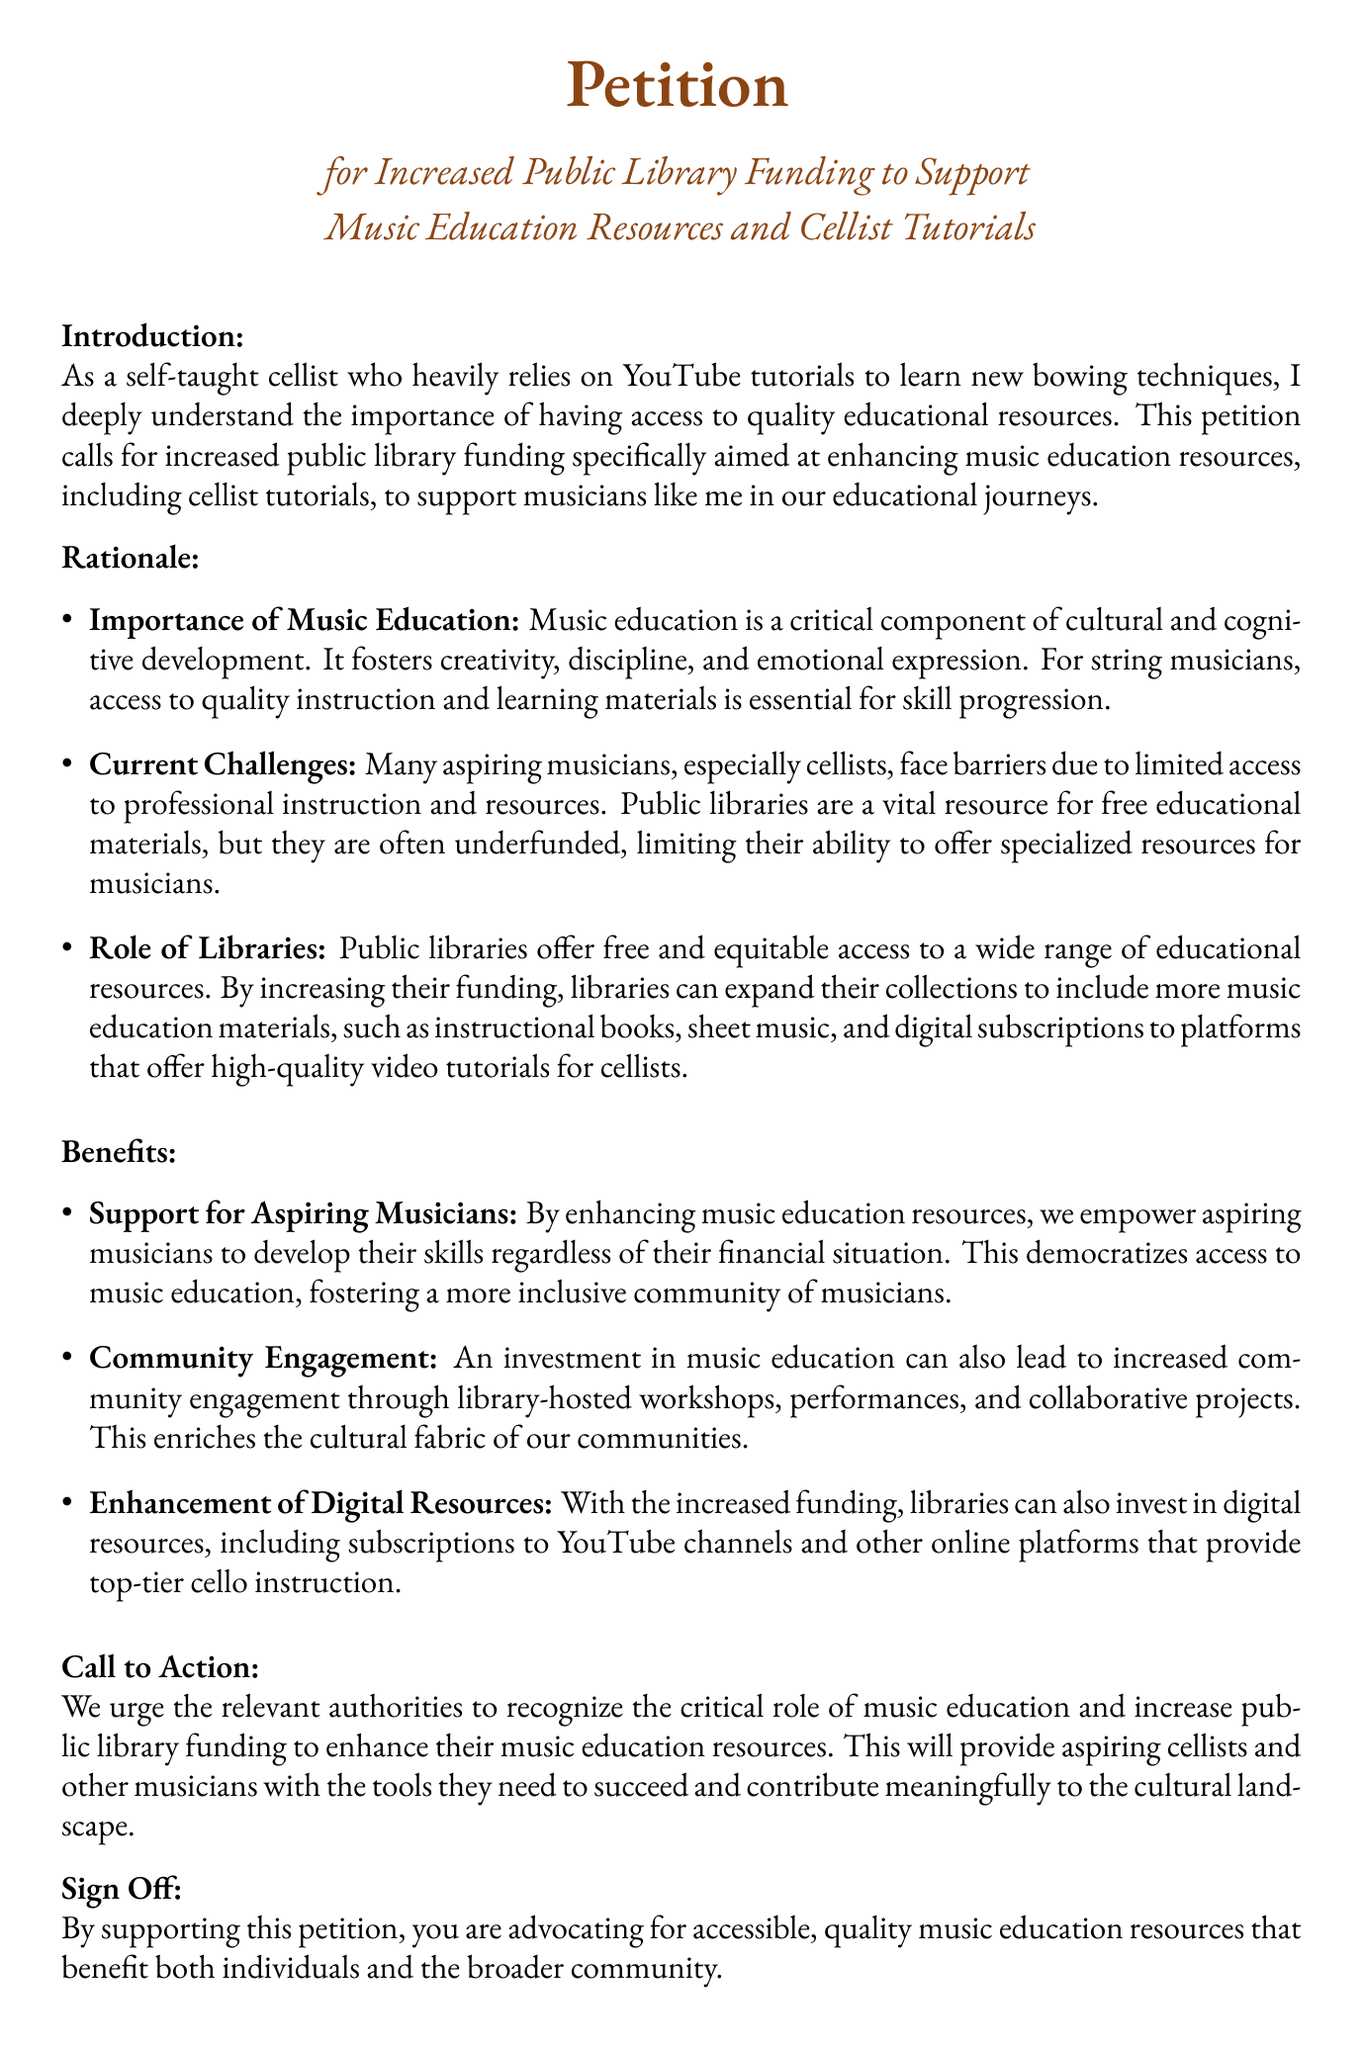What is the title of the petition? The title is presented prominently at the beginning of the document which states the aim of the petition.
Answer: Petition for Increased Public Library Funding to Support Music Education Resources and Cellist Tutorials Who is the target audience for the petition? The introduction indicates that the petition is aimed at authorities responsible for public library funding.
Answer: Relevant authorities What is one challenge mentioned regarding music education? The document lists challenges faced by aspiring musicians in accessing professional instruction and resources.
Answer: Limited access What is one proposed benefit of increased library funding? The benefits section outlines advantages like community engagement through music education initiatives.
Answer: Community engagement What does the petition urge authorities to do? The call to action clearly states the petition's request to enhance funding for specific resources.
Answer: Increase public library funding 